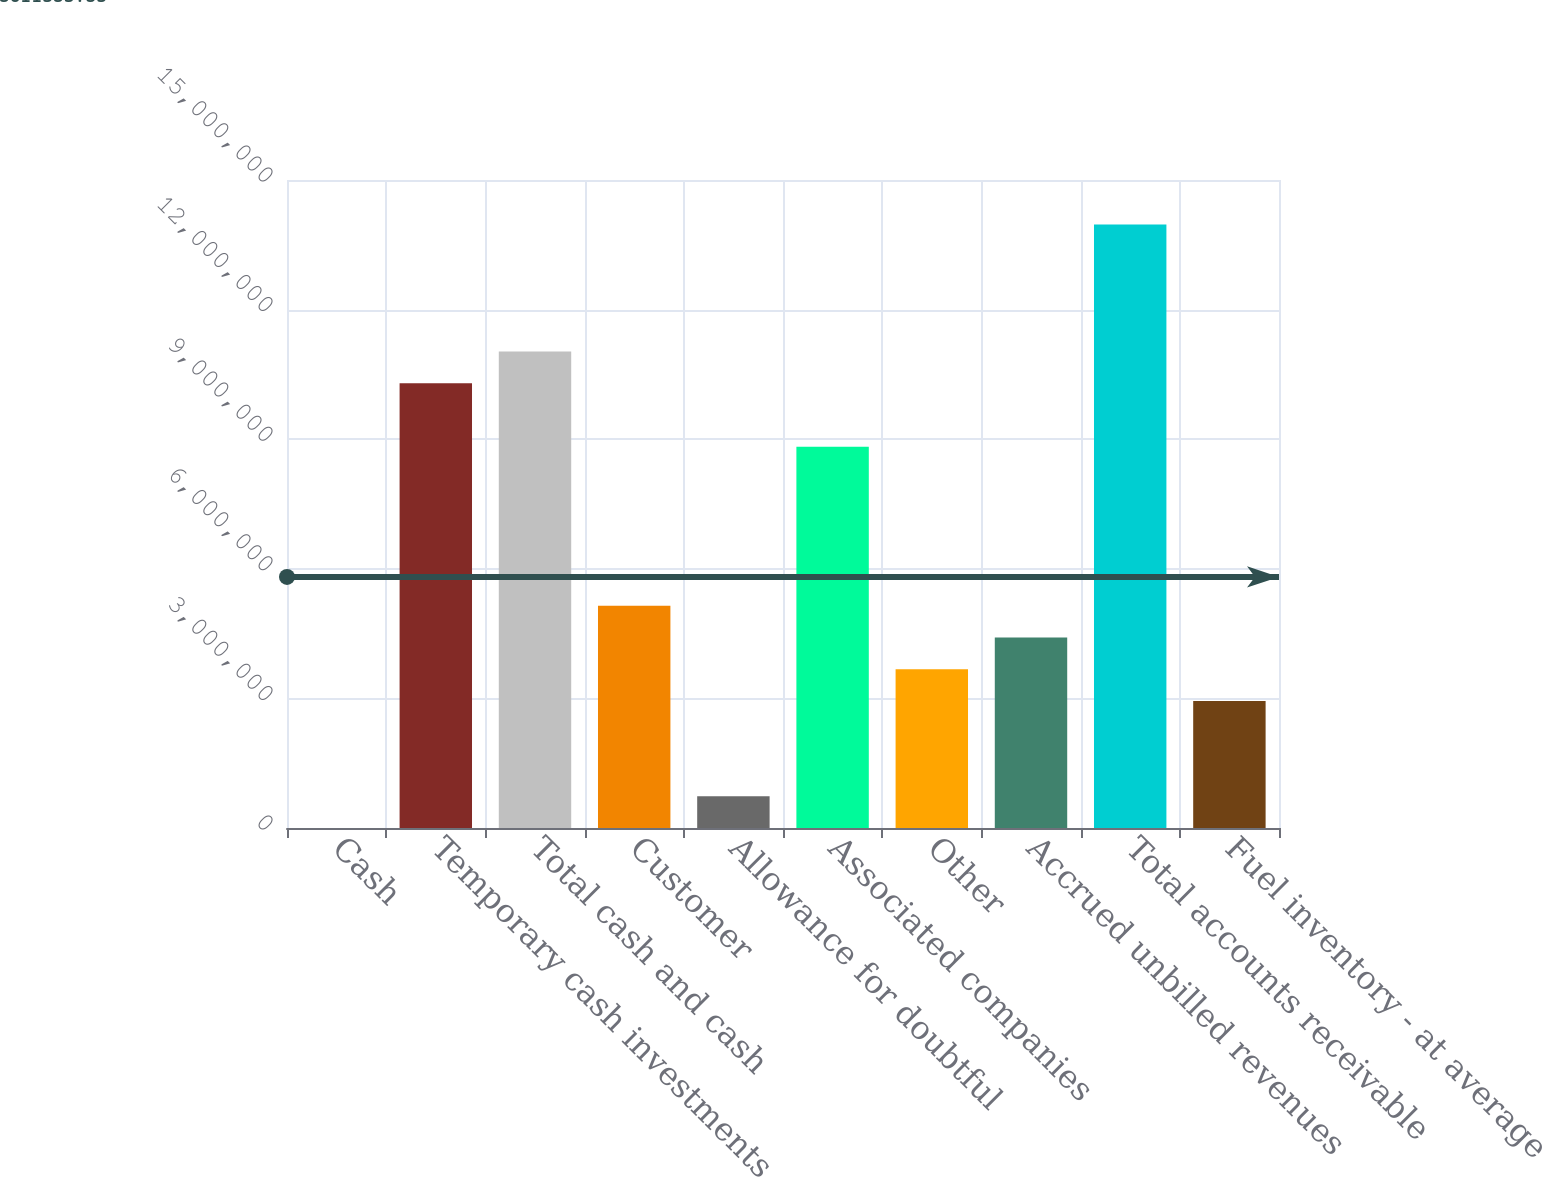<chart> <loc_0><loc_0><loc_500><loc_500><bar_chart><fcel>Cash<fcel>Temporary cash investments<fcel>Total cash and cash<fcel>Customer<fcel>Allowance for doubtful<fcel>Associated companies<fcel>Other<fcel>Accrued unbilled revenues<fcel>Total accounts receivable<fcel>Fuel inventory - at average<nl><fcel>231<fcel>1.0294e+07<fcel>1.10293e+07<fcel>5.14711e+06<fcel>735499<fcel>8.82345e+06<fcel>3.67657e+06<fcel>4.41184e+06<fcel>1.39703e+07<fcel>2.9413e+06<nl></chart> 